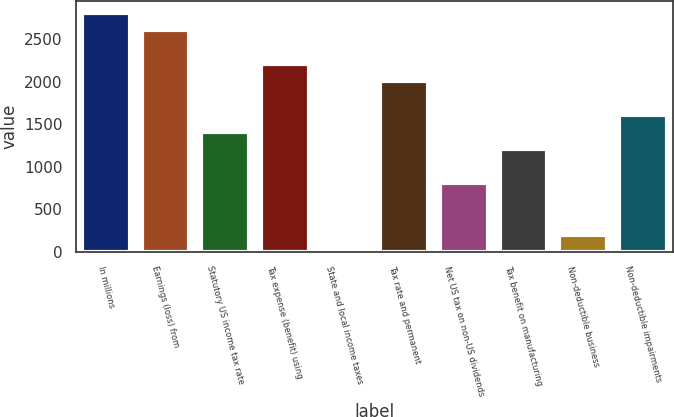<chart> <loc_0><loc_0><loc_500><loc_500><bar_chart><fcel>In millions<fcel>Earnings (loss) from<fcel>Statutory US income tax rate<fcel>Tax expense (benefit) using<fcel>State and local income taxes<fcel>Tax rate and permanent<fcel>Net US tax on non-US dividends<fcel>Tax benefit on manufacturing<fcel>Non-deductible business<fcel>Non-deductible impairments<nl><fcel>2817.4<fcel>2616.3<fcel>1409.7<fcel>2214.1<fcel>2<fcel>2013<fcel>806.4<fcel>1208.6<fcel>203.1<fcel>1610.8<nl></chart> 